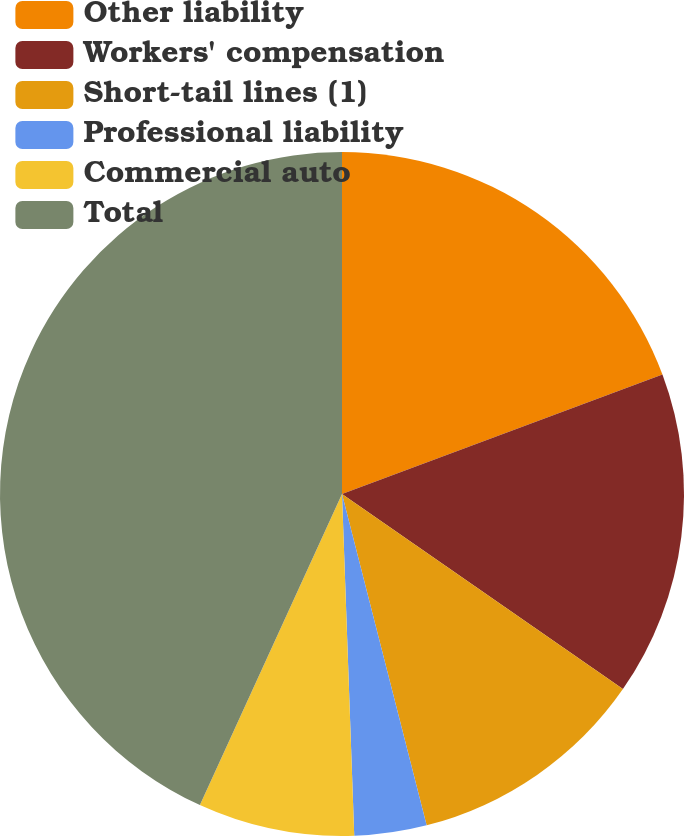Convert chart to OTSL. <chart><loc_0><loc_0><loc_500><loc_500><pie_chart><fcel>Other liability<fcel>Workers' compensation<fcel>Short-tail lines (1)<fcel>Professional liability<fcel>Commercial auto<fcel>Total<nl><fcel>19.32%<fcel>15.34%<fcel>11.36%<fcel>3.41%<fcel>7.39%<fcel>43.18%<nl></chart> 